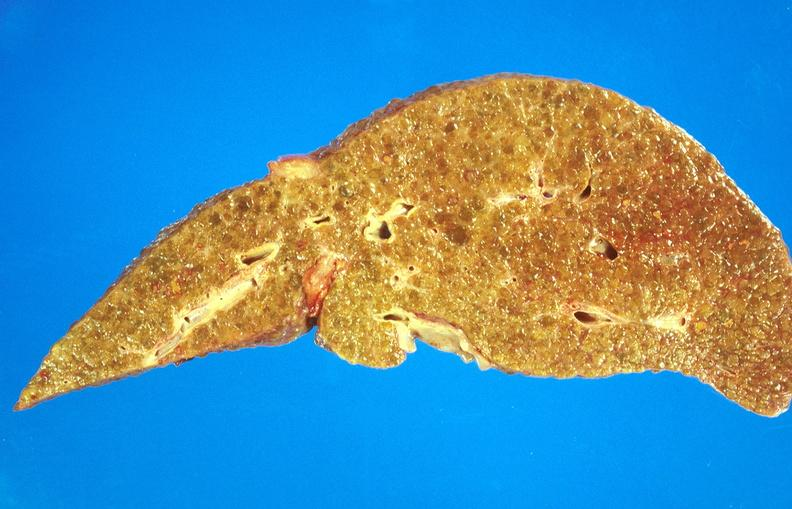does cervix duplication show alcoholic cirrhosis?
Answer the question using a single word or phrase. No 